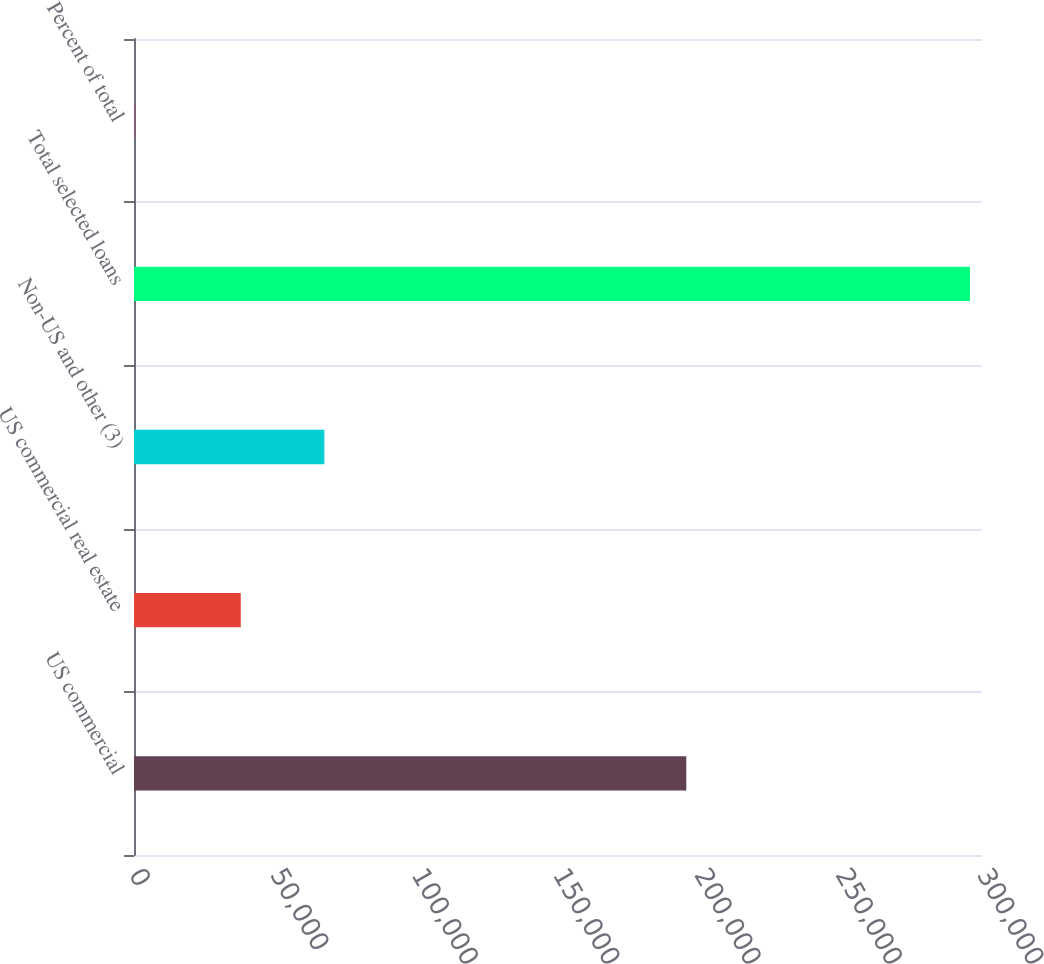<chart> <loc_0><loc_0><loc_500><loc_500><bar_chart><fcel>US commercial<fcel>US commercial real estate<fcel>Non-US and other (3)<fcel>Total selected loans<fcel>Percent of total<nl><fcel>195387<fcel>37770<fcel>67335.7<fcel>295757<fcel>100<nl></chart> 